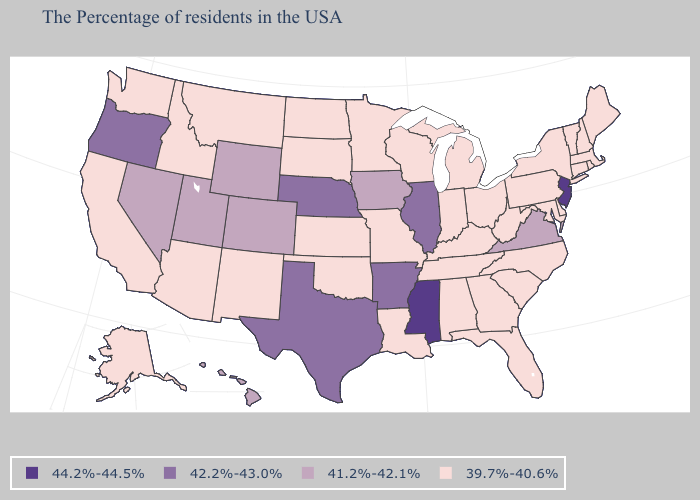Does Maine have the highest value in the USA?
Keep it brief. No. Does the map have missing data?
Write a very short answer. No. Name the states that have a value in the range 44.2%-44.5%?
Write a very short answer. New Jersey, Mississippi. What is the value of Connecticut?
Quick response, please. 39.7%-40.6%. Does the first symbol in the legend represent the smallest category?
Write a very short answer. No. Does Hawaii have a higher value than New York?
Give a very brief answer. Yes. Name the states that have a value in the range 44.2%-44.5%?
Give a very brief answer. New Jersey, Mississippi. What is the value of Montana?
Concise answer only. 39.7%-40.6%. How many symbols are there in the legend?
Write a very short answer. 4. Does Colorado have the highest value in the USA?
Keep it brief. No. What is the highest value in the USA?
Give a very brief answer. 44.2%-44.5%. What is the lowest value in the USA?
Short answer required. 39.7%-40.6%. Does New Jersey have the highest value in the Northeast?
Concise answer only. Yes. Name the states that have a value in the range 42.2%-43.0%?
Quick response, please. Illinois, Arkansas, Nebraska, Texas, Oregon. What is the value of Missouri?
Write a very short answer. 39.7%-40.6%. 